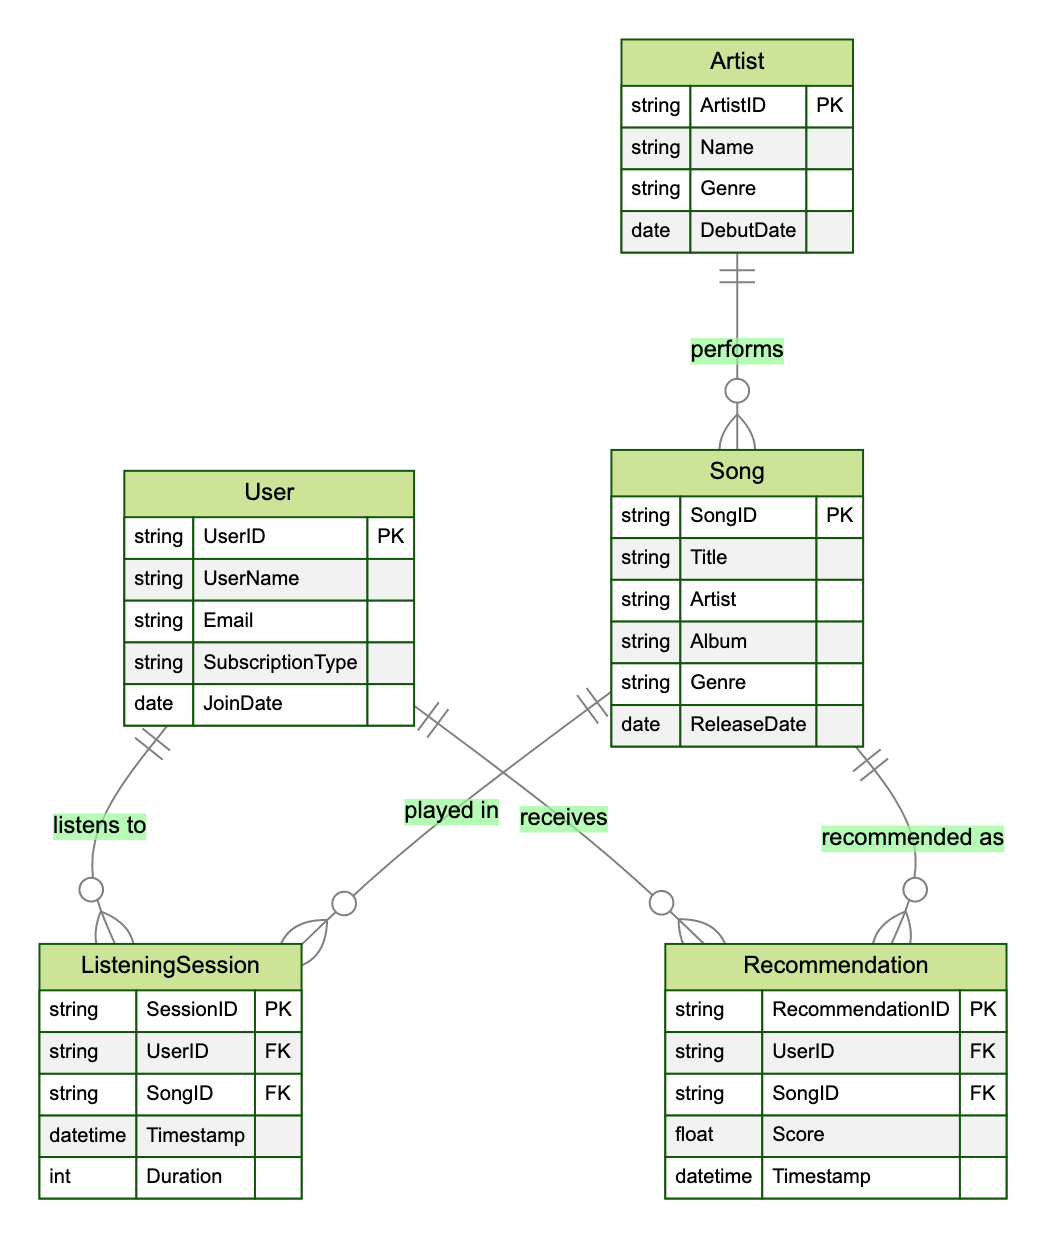What are the attributes of the User entity? The User entity has five attributes: UserID, UserName, Email, SubscriptionType, and JoinDate. These can be clearly seen listed under the User node in the diagram.
Answer: UserID, UserName, Email, SubscriptionType, JoinDate How many attributes does the Song entity have? The Song entity contains six attributes: SongID, Title, Artist, Album, Genre, and ReleaseDate. The total can be counted from the list of attributes under the Song node.
Answer: 6 What is the relationship type between User and ListeningSession? The relationship between User and ListeningSession is labeled as "one-to-many." This means each User can have multiple ListeningSessions. The notation in the diagram indicates this relationship type.
Answer: one-to-many How many relationships are there overall in the diagram? There are three relationships indicated in the diagram: Listen, Recommend, and Performs. Counting these labeled relationships provides the total.
Answer: 3 Which entity has a one-to-many relationship with the Song entity? The entity that has a one-to-many relationship with the Song entity is Artist. This can be determined by looking at the relationship labeled "performs" which connects Artist to Song.
Answer: Artist What is the duration attribute associated with? The duration attribute is associated with the ListeningSession entity. In the diagram, it is specifically listed under the ListeningSession attributes.
Answer: ListeningSession What does the Recommendation entity track? The Recommendation entity tracks recommendations given to users, as indicated by its attributes including RecommendationID, UserID, SongID, Score, and Timestamp. This can be understood from the context and the attributes specified in the diagram.
Answer: recommendations What indicates a many-to-many relationship in the diagram? The relationship between User and Song, labeled as "Recommend," indicates a many-to-many relationship. This is specifically shown by the symbols used in the diagram representing this type of connection.
Answer: Recommend Which entity directly connects to the ListeningSession? The entities that directly connect to ListeningSession are User and Song. Both of these are illustrated within the "listens to" and "played in" relationships in the diagram.
Answer: User and Song 